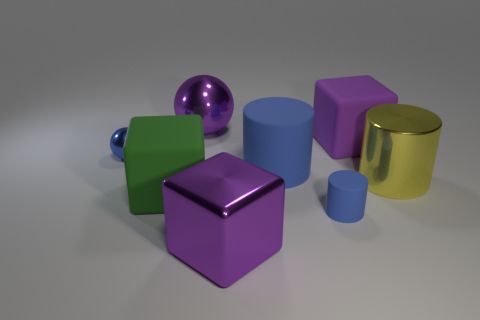Subtract all gray cylinders. Subtract all brown cubes. How many cylinders are left? 3 Add 1 big purple things. How many objects exist? 9 Subtract all cylinders. How many objects are left? 5 Subtract all tiny metallic things. Subtract all tiny balls. How many objects are left? 6 Add 8 large rubber cylinders. How many large rubber cylinders are left? 9 Add 5 cyan balls. How many cyan balls exist? 5 Subtract 0 cyan cubes. How many objects are left? 8 